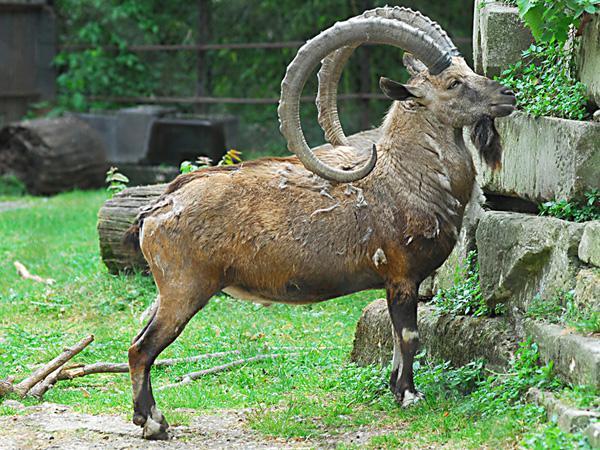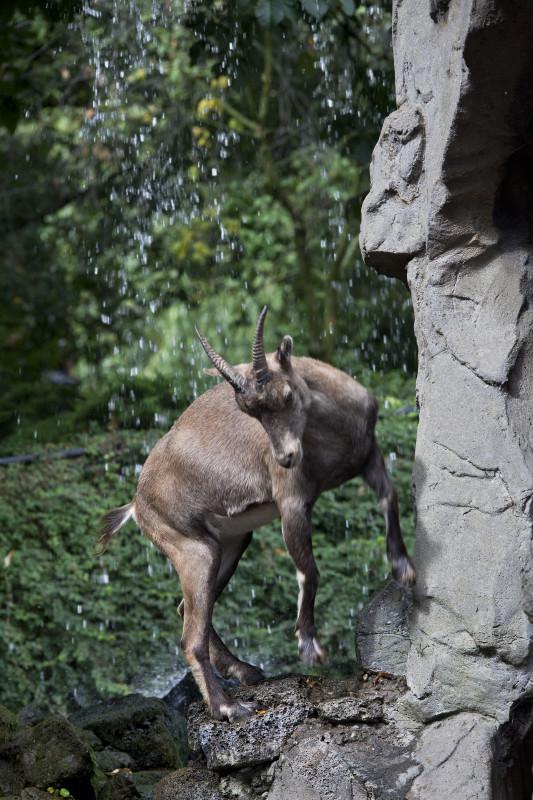The first image is the image on the left, the second image is the image on the right. For the images shown, is this caption "The left image has a single mammal looking to the right, the right image has a single mammal not looking to the right." true? Answer yes or no. Yes. The first image is the image on the left, the second image is the image on the right. Examine the images to the left and right. Is the description "The left and right image contains the same number of goats with at least one one rocks." accurate? Answer yes or no. Yes. 